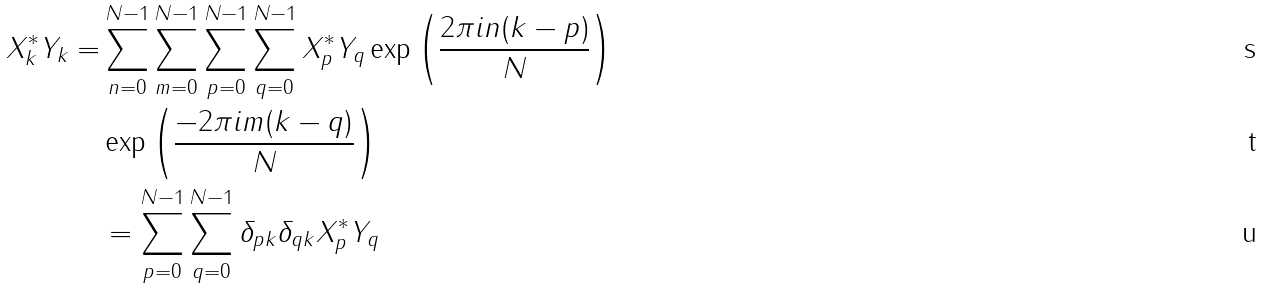<formula> <loc_0><loc_0><loc_500><loc_500>X _ { k } ^ { * } Y _ { k } = & \sum _ { n = 0 } ^ { N - 1 } \sum _ { m = 0 } ^ { N - 1 } \sum _ { p = 0 } ^ { N - 1 } \sum _ { q = 0 } ^ { N - 1 } X _ { p } ^ { * } Y _ { q } \exp \left ( { \frac { 2 \pi i n ( k - p ) } { N } } \right ) \\ & \exp \left ( { \frac { - 2 \pi i m ( k - q ) } { N } } \right ) \\ & = \sum _ { p = 0 } ^ { N - 1 } \sum _ { q = 0 } ^ { N - 1 } \delta _ { p k } \delta _ { q k } X _ { p } ^ { * } Y _ { q }</formula> 